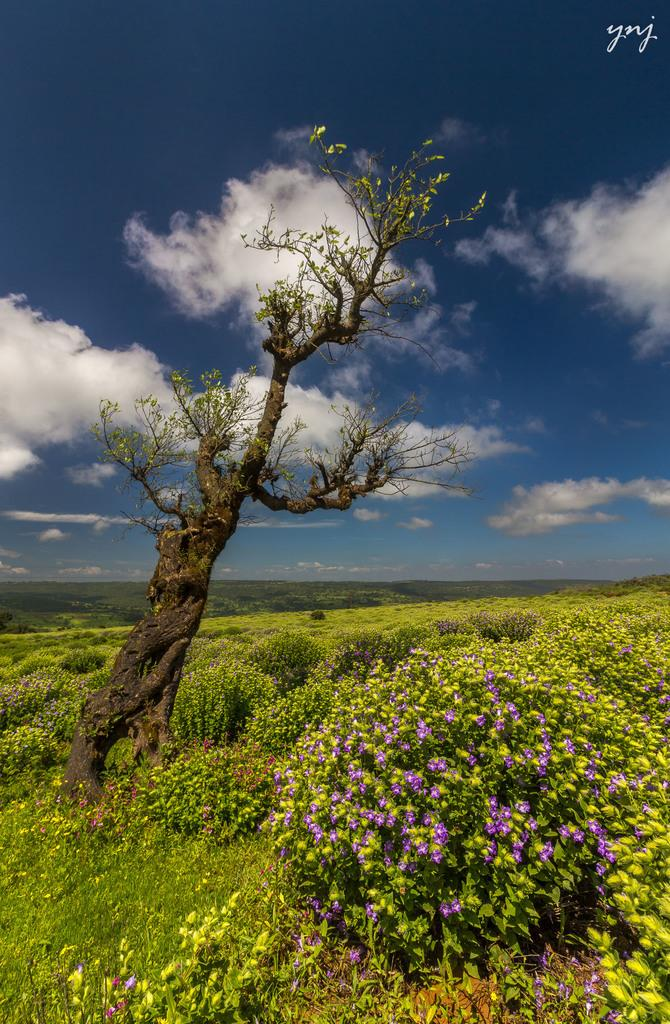What is located on the left side of the image? There is a tree on the left side of the image. What type of terrain is the tree situated on? The tree is on grass land. What other types of vegetation can be seen in the image? There are many plants in the image. What is visible in the background of the image? The sky is visible in the image. What can be observed in the sky? Clouds are present in the sky. What type of food is the father eating during the holiday in the image? There is no food, father, or holiday depicted in the image; it features a tree, grass land, plants, and a sky with clouds. 